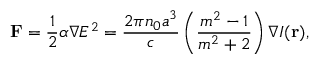Convert formula to latex. <formula><loc_0><loc_0><loc_500><loc_500>F = { \frac { 1 } { 2 } } \alpha \nabla E ^ { 2 } = { \frac { 2 \pi n _ { 0 } a ^ { 3 } } { c } } \left ( { \frac { m ^ { 2 } - 1 } { m ^ { 2 } + 2 } } \right ) \nabla I ( r ) ,</formula> 